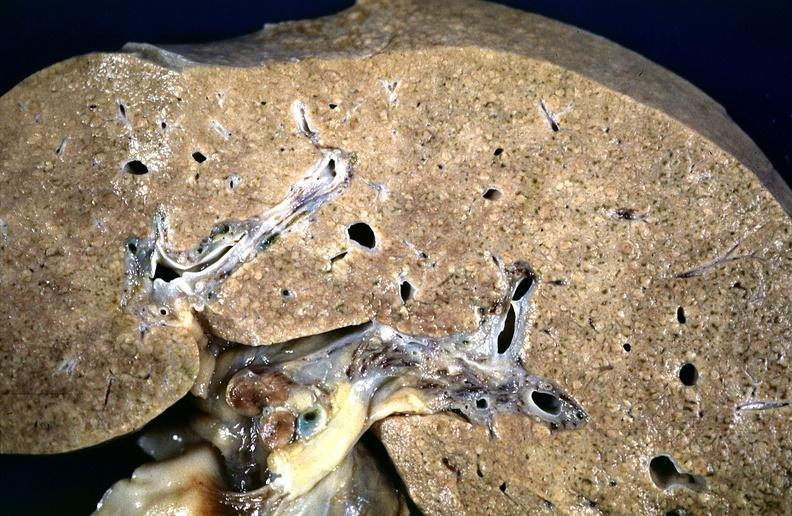s alpha smooth muscle actin immunohistochemical present?
Answer the question using a single word or phrase. No 